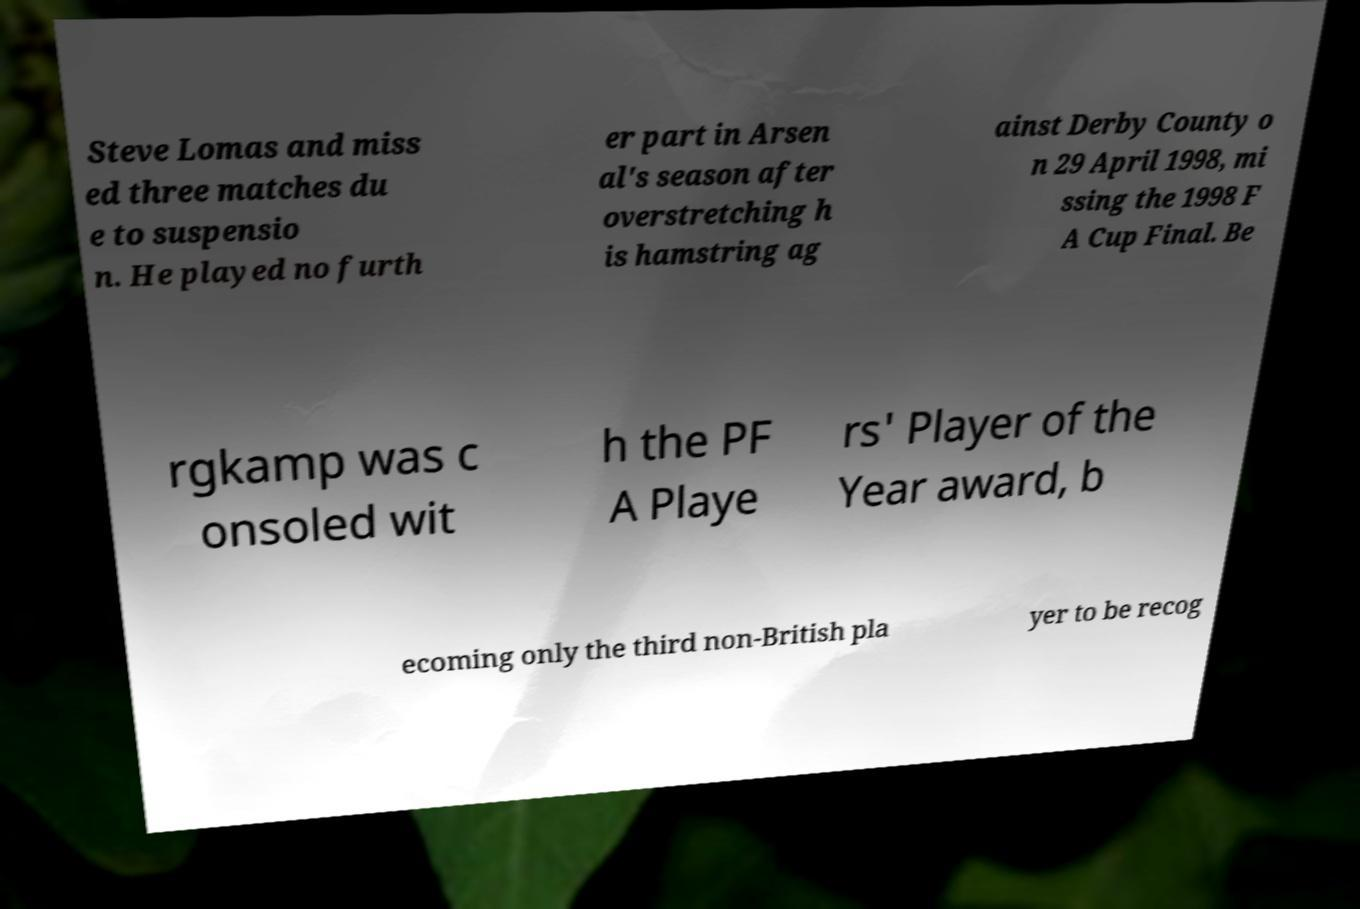For documentation purposes, I need the text within this image transcribed. Could you provide that? Steve Lomas and miss ed three matches du e to suspensio n. He played no furth er part in Arsen al's season after overstretching h is hamstring ag ainst Derby County o n 29 April 1998, mi ssing the 1998 F A Cup Final. Be rgkamp was c onsoled wit h the PF A Playe rs' Player of the Year award, b ecoming only the third non-British pla yer to be recog 